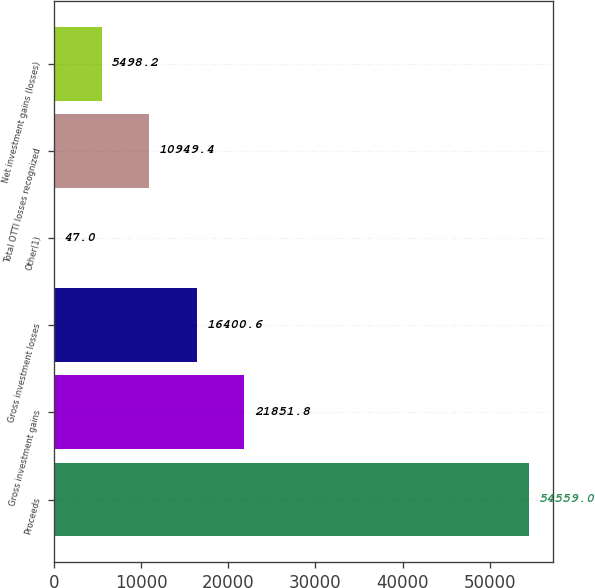Convert chart. <chart><loc_0><loc_0><loc_500><loc_500><bar_chart><fcel>Proceeds<fcel>Gross investment gains<fcel>Gross investment losses<fcel>Other(1)<fcel>Total OTTI losses recognized<fcel>Net investment gains (losses)<nl><fcel>54559<fcel>21851.8<fcel>16400.6<fcel>47<fcel>10949.4<fcel>5498.2<nl></chart> 